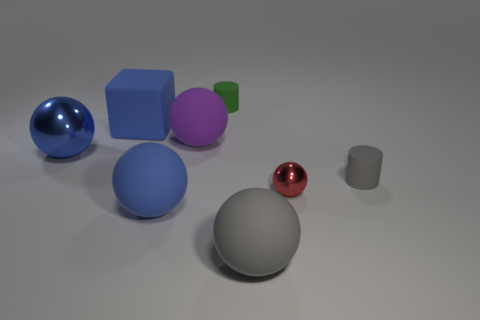Are there fewer tiny green matte cylinders on the right side of the small gray object than big blue objects?
Offer a terse response. Yes. How many large red objects are there?
Your answer should be very brief. 0. What is the shape of the gray matte thing that is right of the metal ball to the right of the purple matte object?
Your answer should be very brief. Cylinder. There is a large blue shiny sphere; how many balls are on the right side of it?
Provide a short and direct response. 4. Is the tiny gray cylinder made of the same material as the large thing right of the purple rubber ball?
Your answer should be very brief. Yes. Are there any matte cubes of the same size as the red ball?
Your response must be concise. No. Are there an equal number of tiny balls that are behind the red metal thing and small rubber things?
Your answer should be very brief. No. The cube has what size?
Keep it short and to the point. Large. How many big purple balls are right of the tiny matte thing that is in front of the green matte thing?
Ensure brevity in your answer.  0. What shape is the small object that is both right of the big gray thing and behind the red metallic ball?
Offer a terse response. Cylinder. 